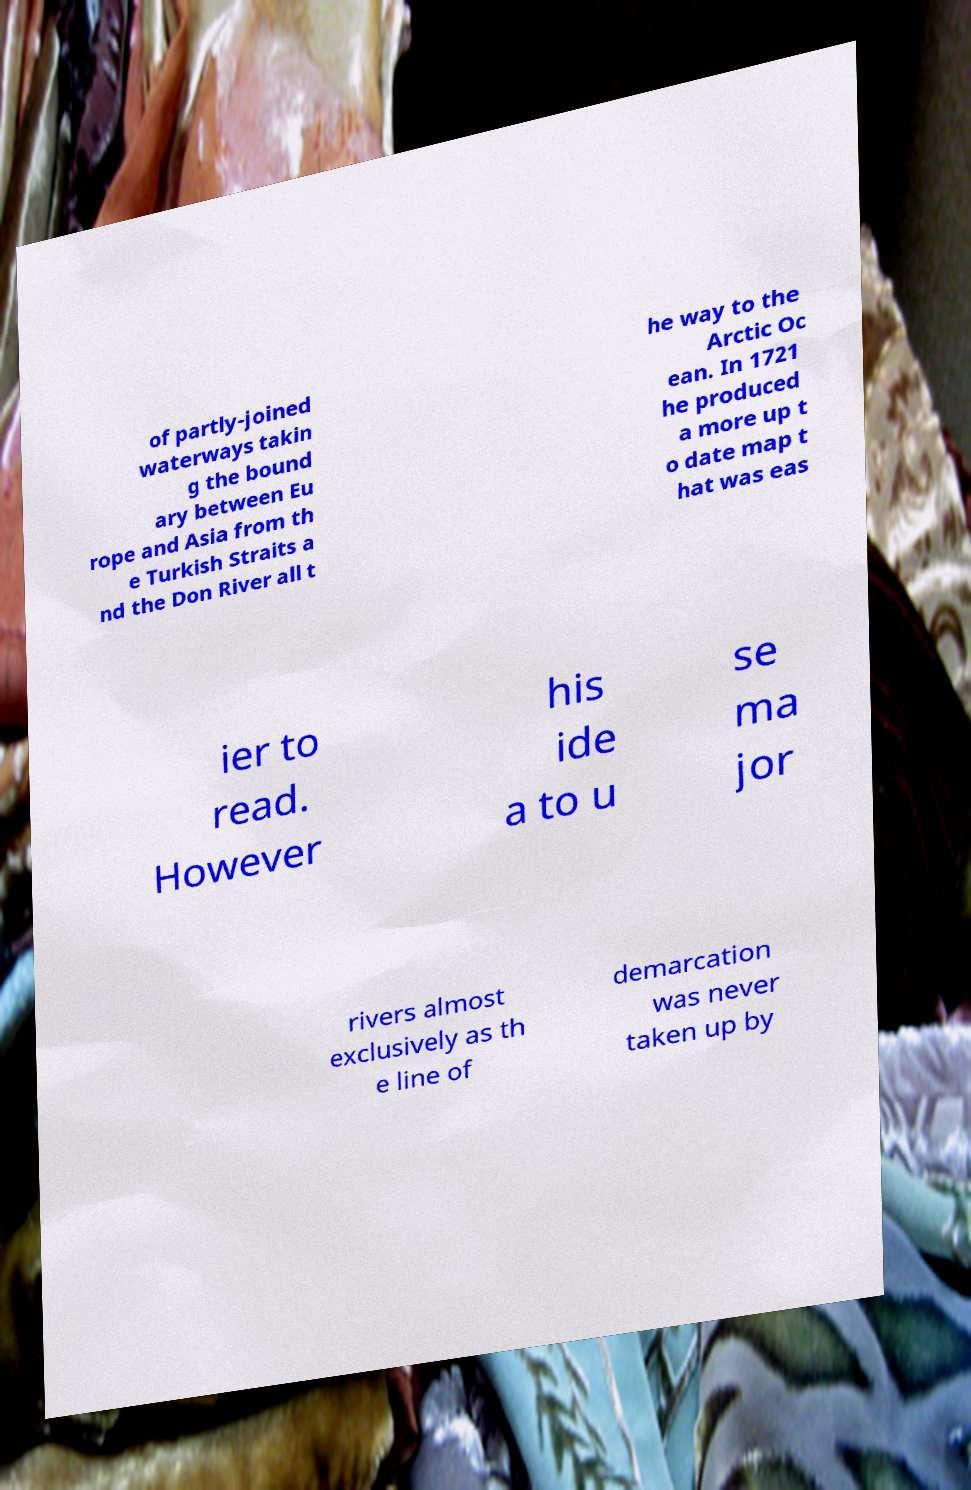For documentation purposes, I need the text within this image transcribed. Could you provide that? of partly-joined waterways takin g the bound ary between Eu rope and Asia from th e Turkish Straits a nd the Don River all t he way to the Arctic Oc ean. In 1721 he produced a more up t o date map t hat was eas ier to read. However his ide a to u se ma jor rivers almost exclusively as th e line of demarcation was never taken up by 